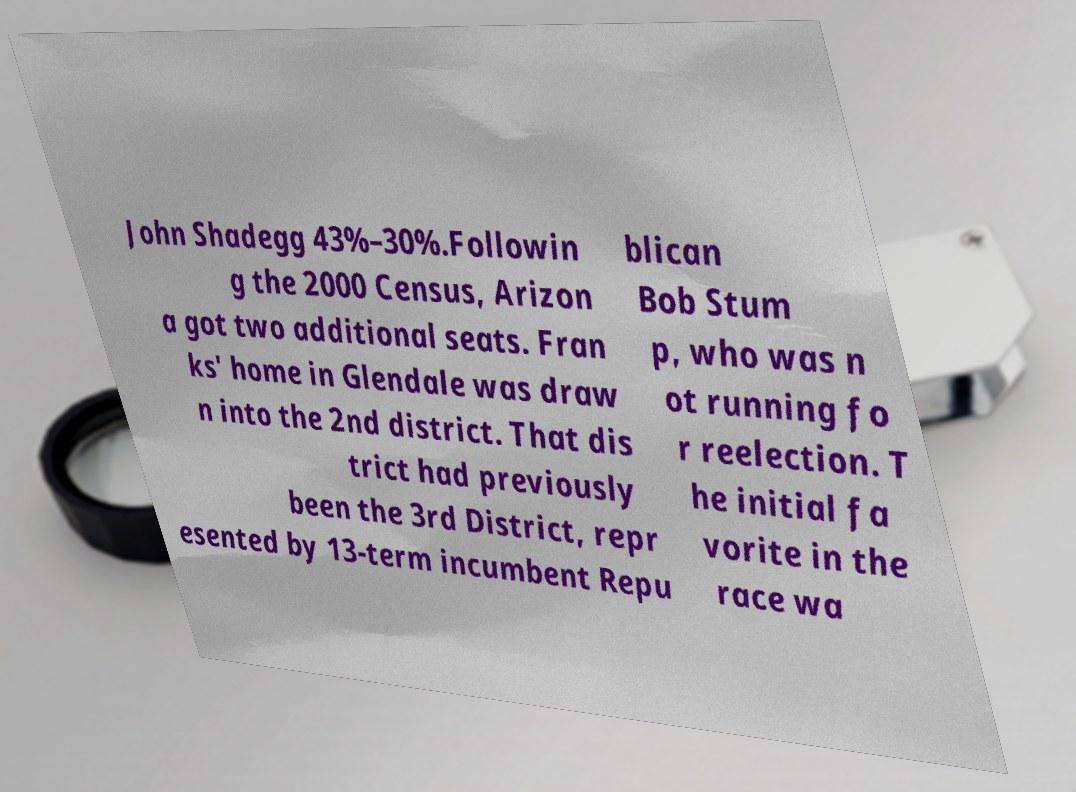Please identify and transcribe the text found in this image. John Shadegg 43%–30%.Followin g the 2000 Census, Arizon a got two additional seats. Fran ks' home in Glendale was draw n into the 2nd district. That dis trict had previously been the 3rd District, repr esented by 13-term incumbent Repu blican Bob Stum p, who was n ot running fo r reelection. T he initial fa vorite in the race wa 